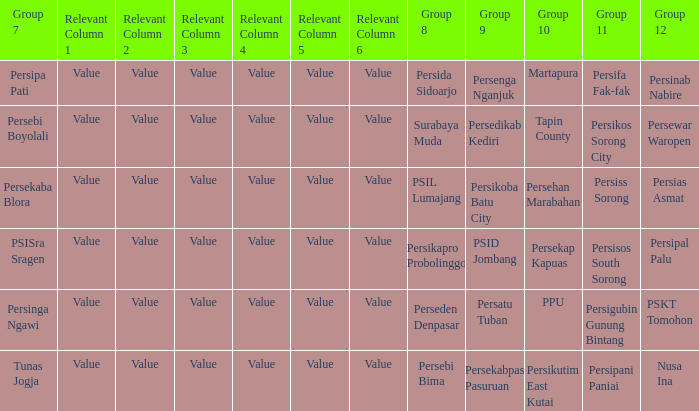Who played in group 11 when Persipal Palu played in group 12? Persisos South Sorong. 